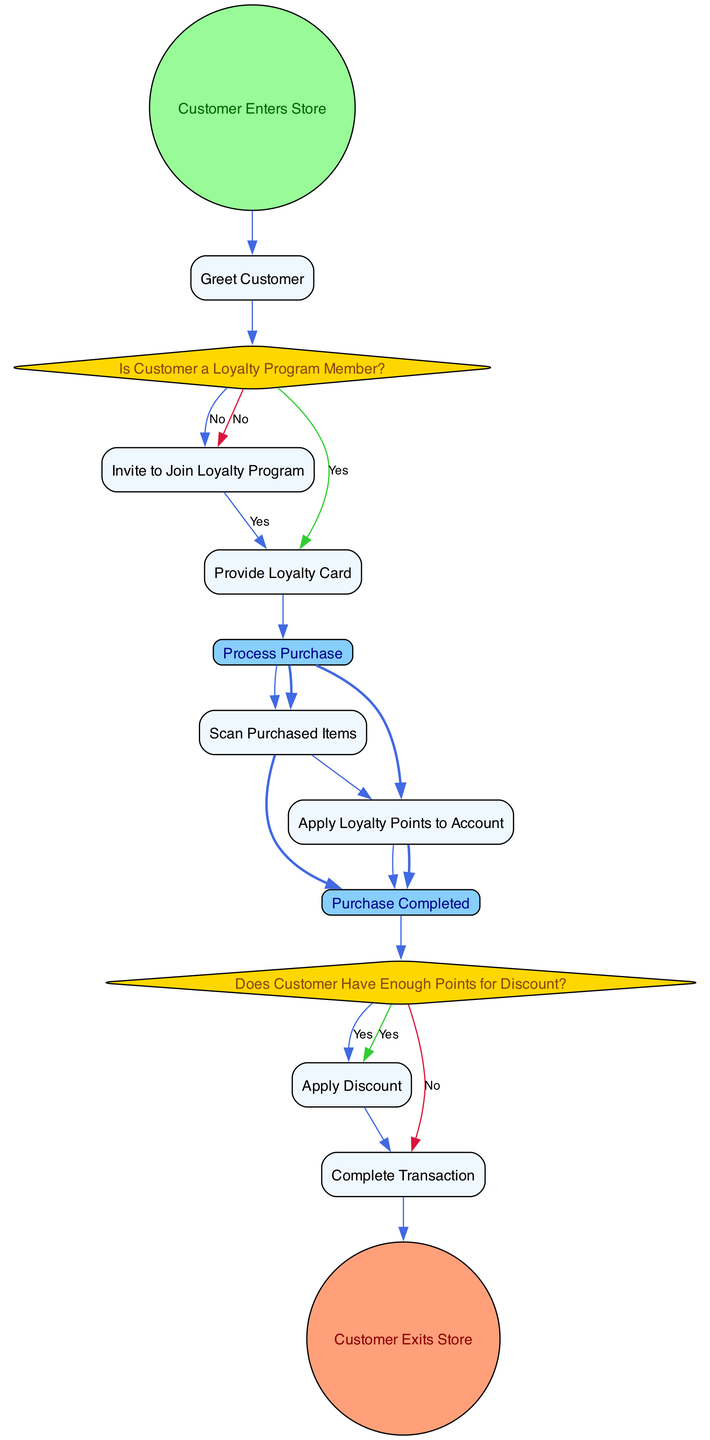What is the first action in the workflow? The workflow begins with the node labeled "Customer Enters Store," indicating that it is the first action taken when initiating the loyalty program workflow.
Answer: Customer Enters Store What is the condition that checks if a customer is part of the loyalty program? The diagram includes a decision node labeled "Is Customer a Loyalty Program Member?" which serves to determine the customer's membership status in the loyalty program.
Answer: Is Customer a Loyalty Program Member? How many action nodes are there in total? By counting all the nodes classified as ActionNode, we find that there are six action nodes in the diagram indicating different actions to be taken.
Answer: Six What happens if the customer is not a loyalty program member? If the customer is not a member, the workflow directs to an action node labeled "Invite to Join Loyalty Program," where the customer is encouraged to sign up for the loyalty program.
Answer: Invite to Join Loyalty Program What is the output if the customer has enough points for a discount? If the customer has enough loyalty points, the workflow proceeds to an action node labeled "Apply Discount," meaning that the discount will be applied to their transaction.
Answer: Apply Discount What is the node that signifies the end of the workflow? The end of the workflow is denoted by the node labeled "Customer Exits Store," indicating the final point of the process after completing the transaction.
Answer: Customer Exits Store Which node follows after "Scan Purchased Items"? After the node "Scan Purchased Items," the next action node is "Apply Loyalty Points to Account," which indicates that loyalty points will be added to the customer's account based on their purchases.
Answer: Apply Loyalty Points to Account What decision node checks for discount eligibility? The diagram includes a decision node titled "Does Customer Have Enough Points for Discount?" This node evaluates whether the customer possesses sufficient points to qualify for a discount.
Answer: Does Customer Have Enough Points for Discount? What indicates the completion of the purchase process? The diagram illustrates a merge node labeled "Purchase Completed," which signifies the successful finalization of the purchase steps before the customer leaves.
Answer: Purchase Completed 